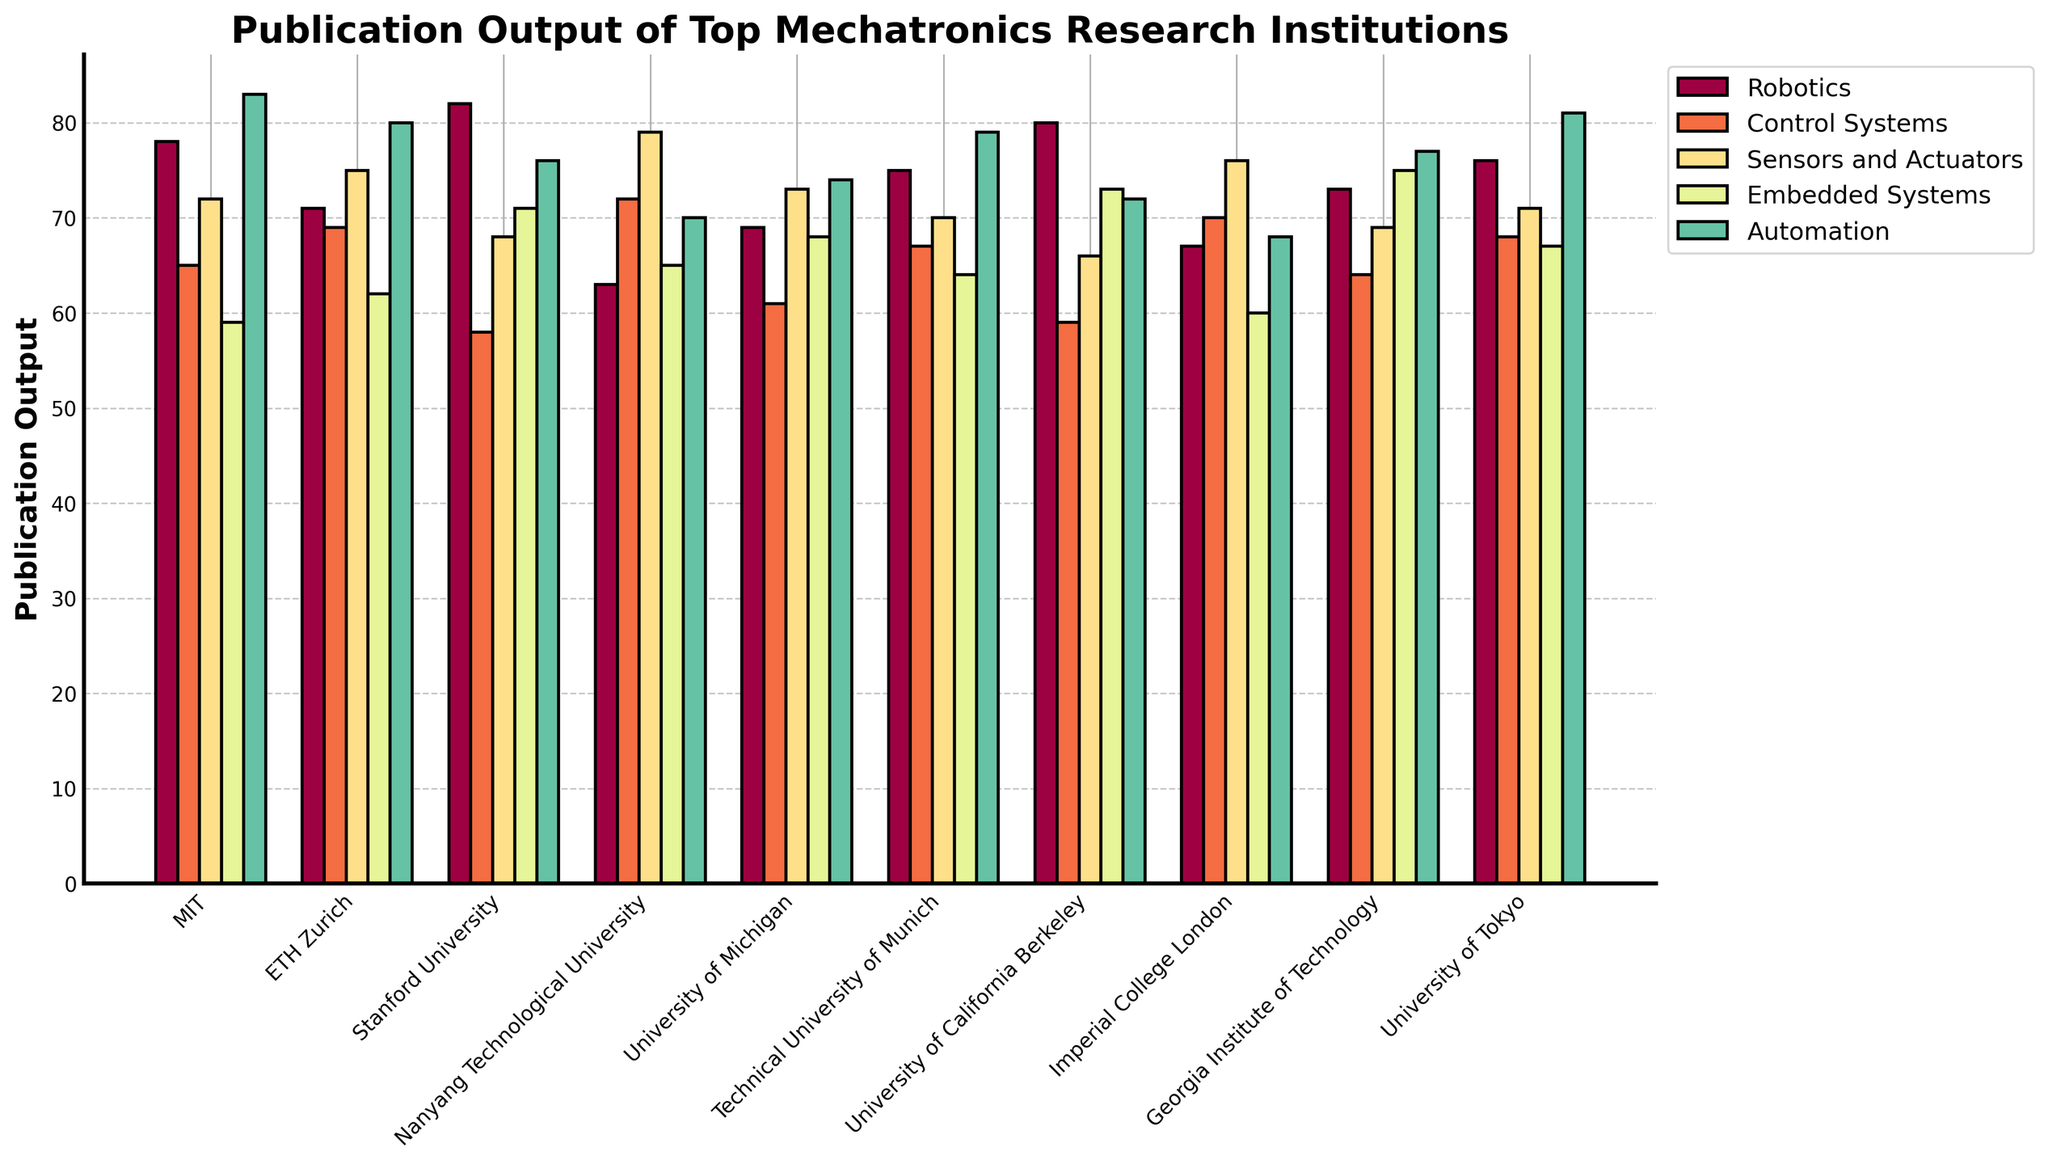Which institution has the highest publication output in Robotics? The tallest bar in the Robotics category (dark red) represents the institution with the highest publication output. By comparing the heights visually, the tallest bar is for Stanford University.
Answer: Stanford University Which institution has the lowest publication output in Embedded Systems? The shortest bar in the Embedded Systems category (medium blue) identifies the institution with the lowest publication output. By observing the bars, MIT has the shortest bar in this category.
Answer: MIT Compare the publication output in Automation between MIT and ETH Zurich. Which institution has more, and by how much? Look at the heights of the bars in the Automation category (orange) for MIT and ETH Zurich. MIT's bar is taller than ETH Zurich's. Subtract ETH Zurich's value (80) from MIT's value (83) to find the difference.
Answer: MIT has 3 more publications than ETH Zurich What is the average publication output in the Control Systems category across all institutions? Sum up the publication outputs for Control Systems (65 + 69 + 58 + 72 + 61 + 67 + 59 + 70 + 64 + 68 = 653) and then divide by the number of institutions (10). The average is 653/10 = 65.3.
Answer: 65.3 Which two institutions have the closest publication outputs in Sensors and Actuators? Compare the values in the Sensors and Actuators column visually and note the differences. The closest values are for MIT (72) and University of Tokyo (71), with a difference of 1 publication.
Answer: MIT and University of Tokyo In which category does Georgia Institute of Technology lead compared to other institutions? Observe the bars corresponding to Georgia Institute of Technology across all categories. The tallest bar for Georgia Institute of Technology in relation to other institutions is in the Embedded Systems category (dark green).
Answer: Embedded Systems What is the combined publication output for Stanford University in Control Systems and Automation? Add the values for Control Systems and Automation for Stanford University (58 + 76). The combined output is 58 + 76 = 134.
Answer: 134 Which category shows the most variation in publication outputs among the institutions? To determine this, examine the heights of the bars within each category and identify the category with the greatest range between the highest and lowest bars. The Control Systems category (65 to 72) spans 7 publications, which shows considerable variation.
Answer: Control Systems Considering all categories, which institution has the highest overall publication output? Sum up the publication outputs for each institution across all categories, then compare the totals. For example, for MIT: 78 + 65 + 72 + 59 + 83 = 357. Repeat this for all institutions and identify the maximum sum. MIT has the highest overall total.
Answer: MIT How does the publication output of Embedded Systems for University of California Berkeley compare to the category's average? First, compute the category average for Embedded Systems: (59 + 62 + 71 + 65 + 68 + 64 + 73 + 60 + 75 + 67) / 10 = 66.4. Berkeley's output is 73. Compare it to the average: 73 > 66.4
Answer: University of California Berkeley has above-average output in Embedded Systems 